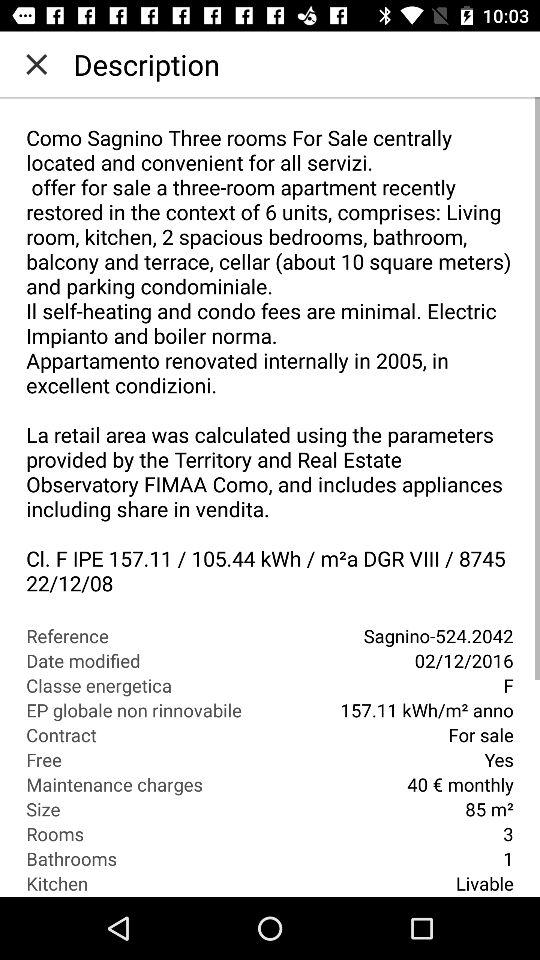What is the size given there? The given size is 85 m². 